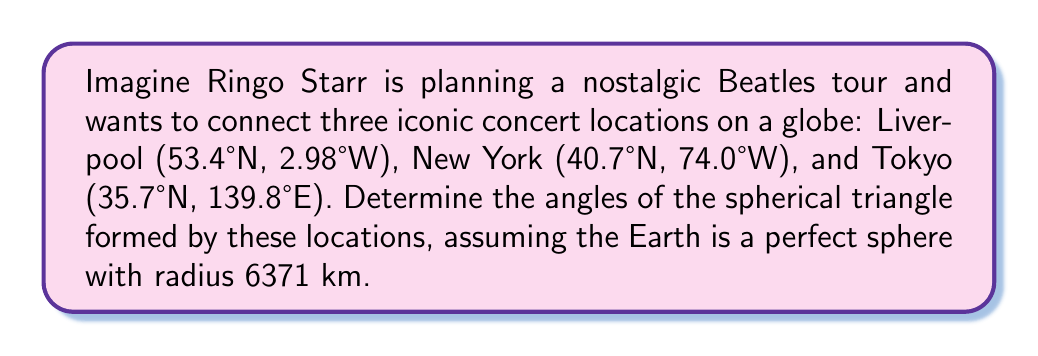Show me your answer to this math problem. Let's approach this step-by-step using spherical trigonometry:

1) First, we need to convert the locations to radians:
   Liverpool: (0.9321, -0.0520)
   New York: (0.7101, -1.2915)
   Tokyo: (0.6230, 2.4400)

2) Calculate the great circle distances (central angles) between the points using the spherical law of cosines:

   $$\cos(c) = \sin(a_1)\sin(a_2) + \cos(a_1)\cos(a_2)\cos(b_1-b_2)$$

   Where $a$ is latitude, $b$ is longitude, and $c$ is the central angle.

   Liverpool-New York (A): 0.9935 radians
   New York-Tokyo (B): 1.9787 radians
   Tokyo-Liverpool (C): 1.5708 radians

3) Now we can use the spherical law of cosines to find the angles:

   $$\cos(a) = \frac{\cos(A) - \cos(B)\cos(C)}{\sin(B)\sin(C)}$$

   Where $a$ is the angle we're solving for, and $A$, $B$, $C$ are the opposite sides.

4) Solving for each angle:

   Liverpool angle: $$\cos^{-1}(\frac{\cos(0.9935) - \cos(1.9787)\cos(1.5708)}{\sin(1.9787)\sin(1.5708)}) = 1.5700 \text{ radians}$$

   New York angle: $$\cos^{-1}(\frac{\cos(1.9787) - \cos(0.9935)\cos(1.5708)}{\sin(0.9935)\sin(1.5708)}) = 0.7854 \text{ radians}$$

   Tokyo angle: $$\cos^{-1}(\frac{\cos(1.5708) - \cos(0.9935)\cos(1.9787)}{\sin(0.9935)\sin(1.9787)}) = 0.7854 \text{ radians}$$

5) Convert to degrees:
   Liverpool: 89.97°
   New York: 45.00°
   Tokyo: 45.00°

[asy]
import geometry;

size(200);
pair A = dir(90);
pair B = dir(-45);
pair C = dir(225);

draw(arc(O,1,90,315), blue);
draw(arc(O,1,-45,90), blue);
draw(arc(O,1,225,-45), blue);

label("Liverpool", A, N);
label("New York", B, SE);
label("Tokyo", C, SW);

dot(A);
dot(B);
dot(C);
[/asy]
Answer: Liverpool: 89.97°, New York: 45.00°, Tokyo: 45.00° 